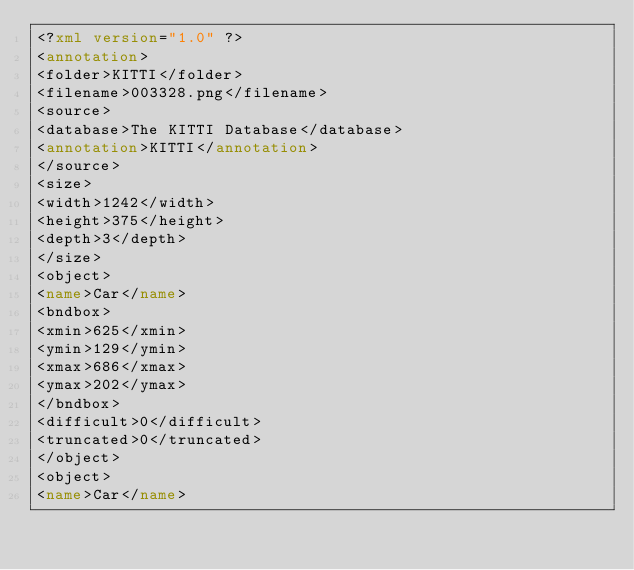Convert code to text. <code><loc_0><loc_0><loc_500><loc_500><_XML_><?xml version="1.0" ?>
<annotation>
<folder>KITTI</folder>
<filename>003328.png</filename>
<source>
<database>The KITTI Database</database>
<annotation>KITTI</annotation>
</source>
<size>
<width>1242</width>
<height>375</height>
<depth>3</depth>
</size>
<object>
<name>Car</name>
<bndbox>
<xmin>625</xmin>
<ymin>129</ymin>
<xmax>686</xmax>
<ymax>202</ymax>
</bndbox>
<difficult>0</difficult>
<truncated>0</truncated>
</object>
<object>
<name>Car</name></code> 